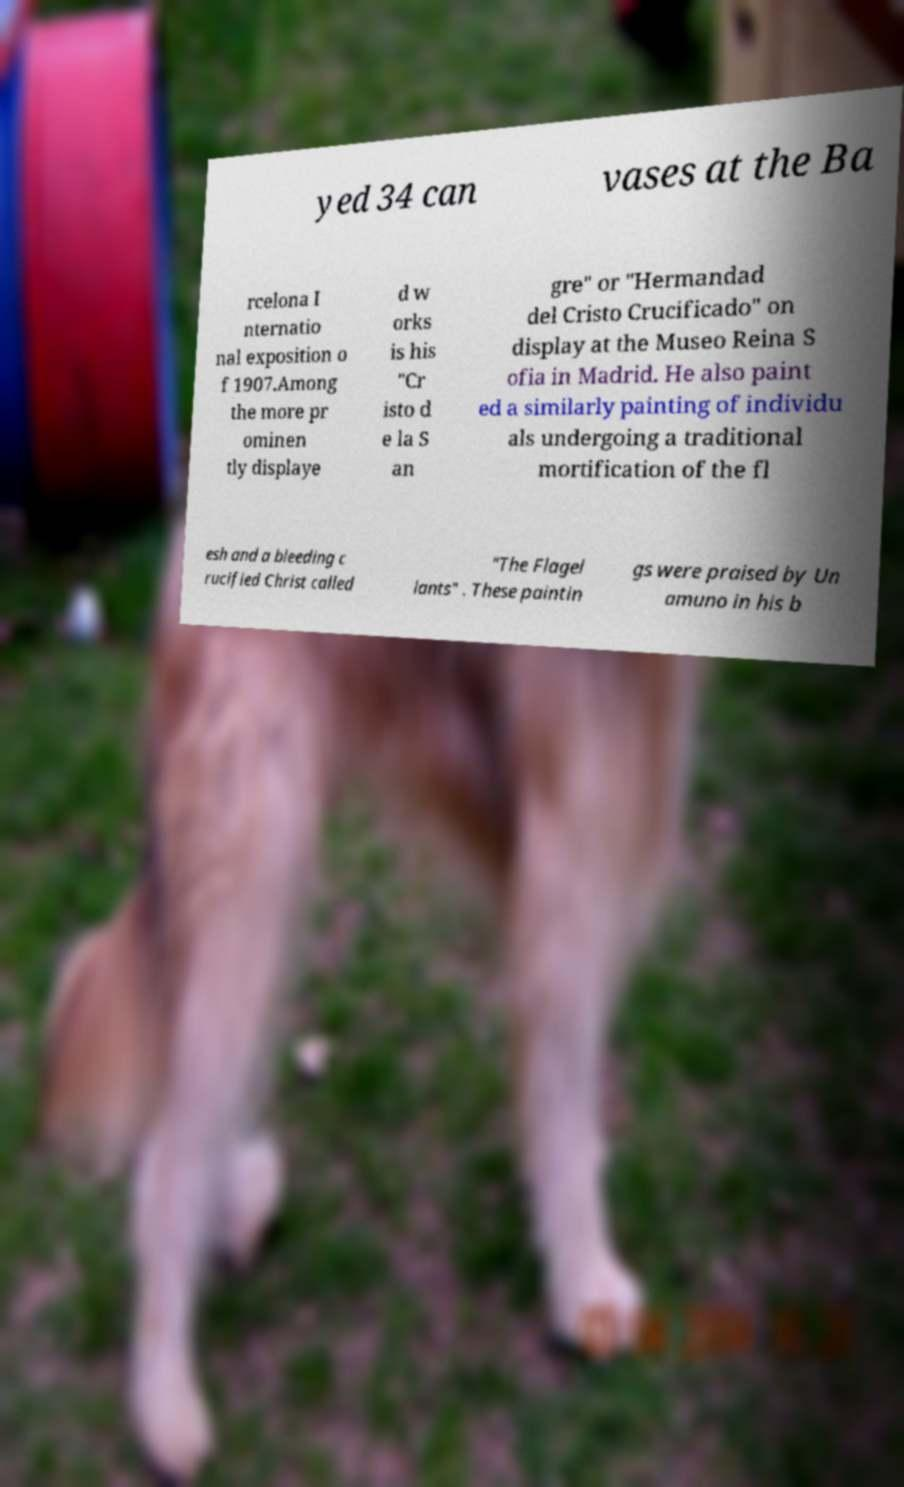Could you extract and type out the text from this image? yed 34 can vases at the Ba rcelona I nternatio nal exposition o f 1907.Among the more pr ominen tly displaye d w orks is his "Cr isto d e la S an gre" or "Hermandad del Cristo Crucificado" on display at the Museo Reina S ofia in Madrid. He also paint ed a similarly painting of individu als undergoing a traditional mortification of the fl esh and a bleeding c rucified Christ called "The Flagel lants" . These paintin gs were praised by Un amuno in his b 